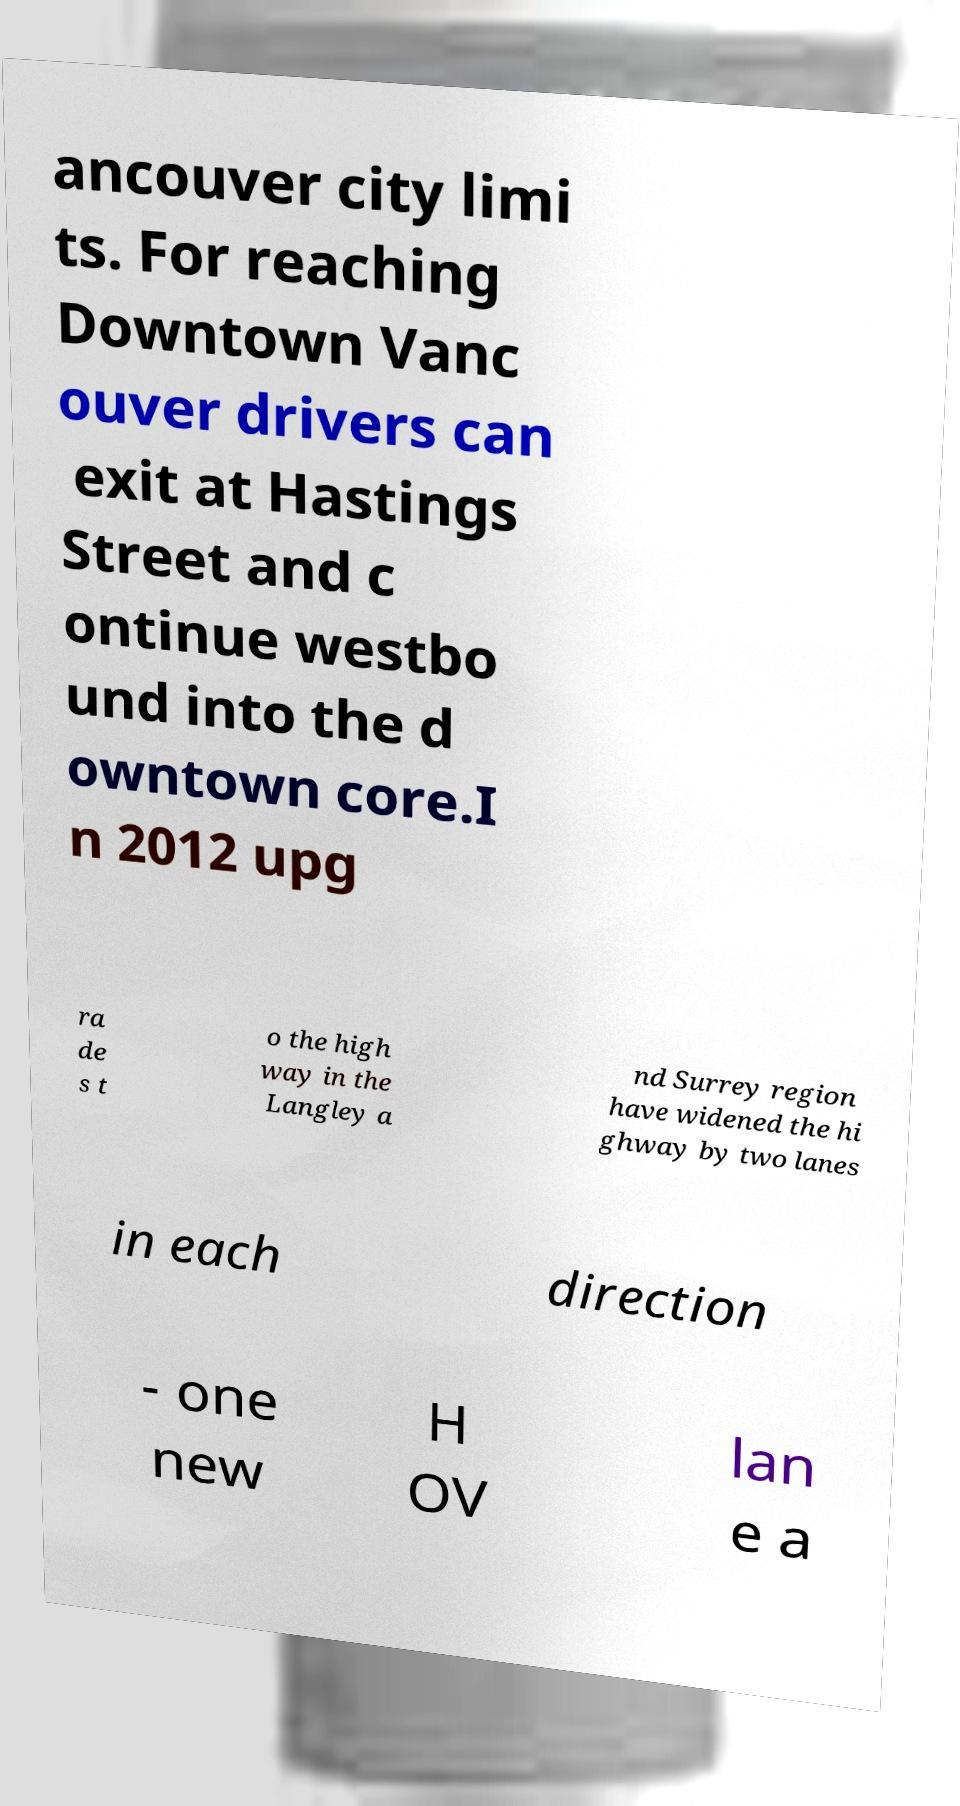Can you accurately transcribe the text from the provided image for me? ancouver city limi ts. For reaching Downtown Vanc ouver drivers can exit at Hastings Street and c ontinue westbo und into the d owntown core.I n 2012 upg ra de s t o the high way in the Langley a nd Surrey region have widened the hi ghway by two lanes in each direction - one new H OV lan e a 